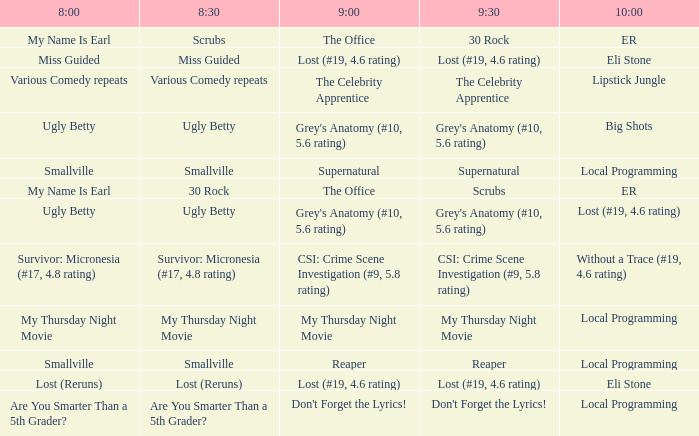What is at 9:30 when at 8:30 it is scrubs? 30 Rock. 